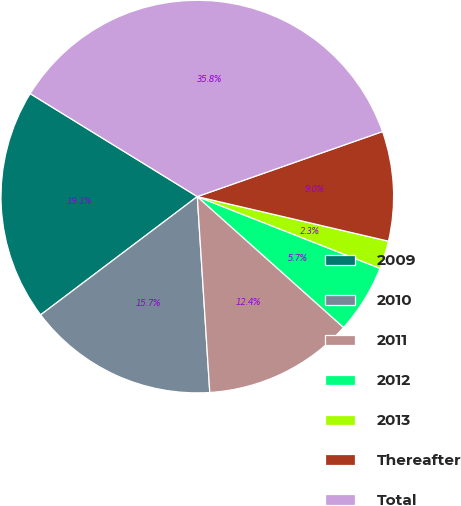Convert chart. <chart><loc_0><loc_0><loc_500><loc_500><pie_chart><fcel>2009<fcel>2010<fcel>2011<fcel>2012<fcel>2013<fcel>Thereafter<fcel>Total<nl><fcel>19.08%<fcel>15.72%<fcel>12.37%<fcel>5.66%<fcel>2.31%<fcel>9.02%<fcel>35.84%<nl></chart> 